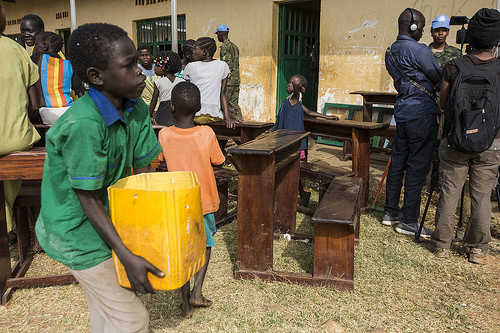<image>
Can you confirm if the girl is on the table? Yes. Looking at the image, I can see the girl is positioned on top of the table, with the table providing support. Is the boy to the left of the table? No. The boy is not to the left of the table. From this viewpoint, they have a different horizontal relationship. Where is the bucket in relation to the boy? Is it under the boy? No. The bucket is not positioned under the boy. The vertical relationship between these objects is different. Is there a window above the box? No. The window is not positioned above the box. The vertical arrangement shows a different relationship. 